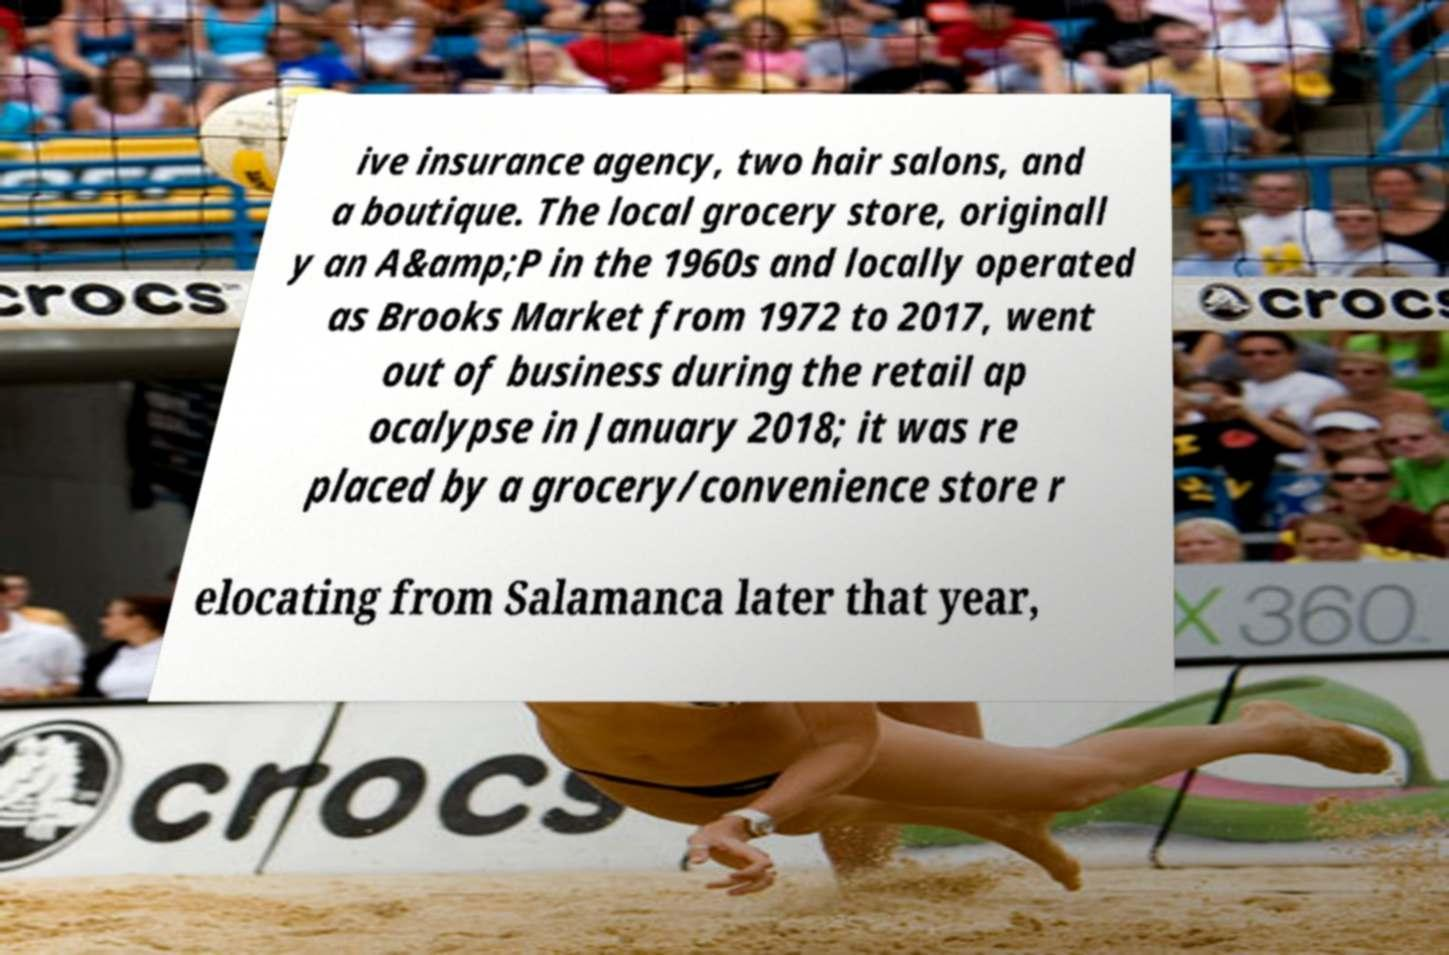For documentation purposes, I need the text within this image transcribed. Could you provide that? ive insurance agency, two hair salons, and a boutique. The local grocery store, originall y an A&amp;P in the 1960s and locally operated as Brooks Market from 1972 to 2017, went out of business during the retail ap ocalypse in January 2018; it was re placed by a grocery/convenience store r elocating from Salamanca later that year, 